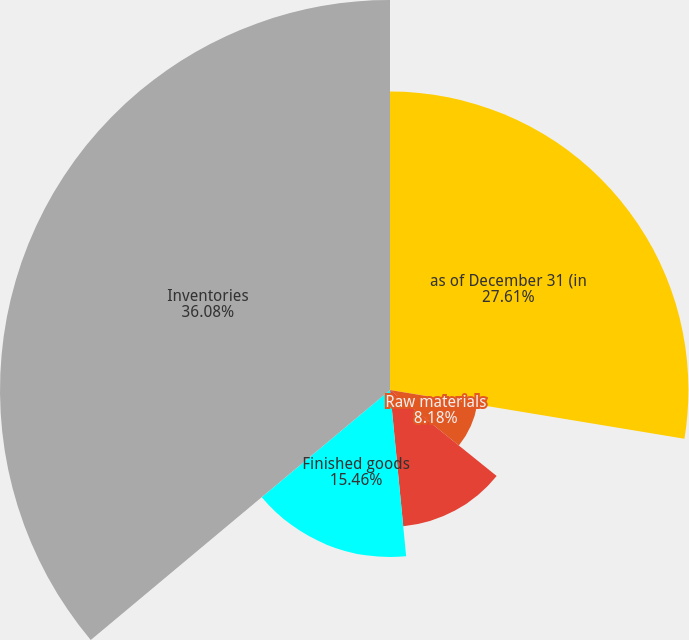Convert chart. <chart><loc_0><loc_0><loc_500><loc_500><pie_chart><fcel>as of December 31 (in<fcel>Raw materials<fcel>Work in process<fcel>Finished goods<fcel>Inventories<nl><fcel>27.61%<fcel>8.18%<fcel>12.67%<fcel>15.46%<fcel>36.08%<nl></chart> 